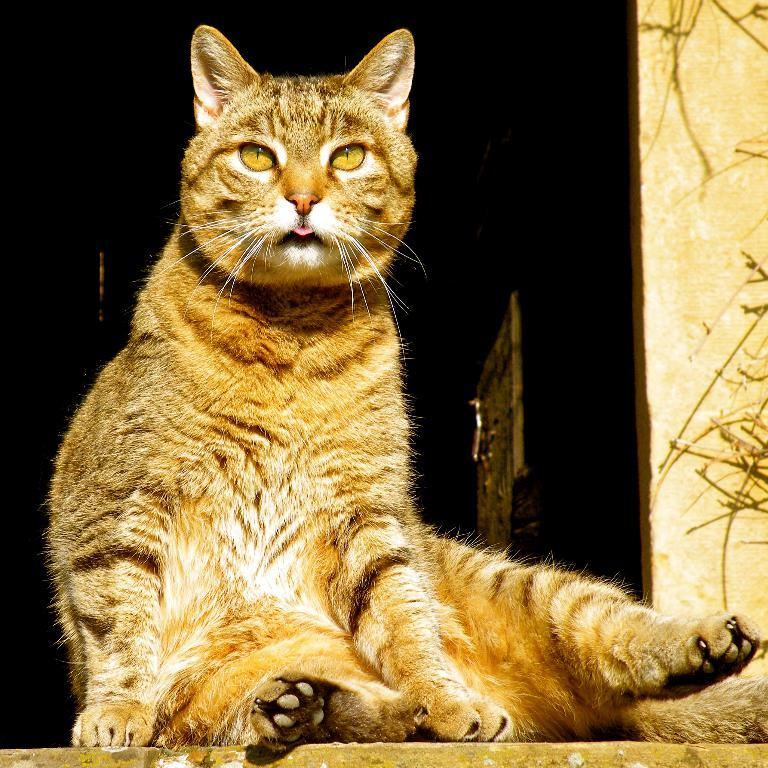What type of animal is in the image? There is a cat in the image. Can you describe the color pattern of the cat? The cat is grey, black, and white in color. How does the cat distribute its toys in the image? There is no information about toys or distribution in the image; it only shows a cat with a specific color pattern. 